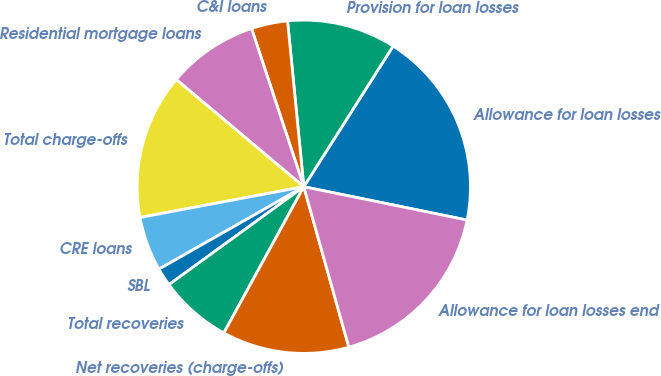<chart> <loc_0><loc_0><loc_500><loc_500><pie_chart><fcel>Allowance for loan losses<fcel>Provision for loan losses<fcel>C&I loans<fcel>Residential mortgage loans<fcel>Total charge-offs<fcel>CRE loans<fcel>SBL<fcel>Total recoveries<fcel>Net recoveries (charge-offs)<fcel>Allowance for loan losses end<nl><fcel>19.2%<fcel>10.56%<fcel>3.52%<fcel>8.8%<fcel>14.08%<fcel>5.28%<fcel>1.76%<fcel>7.04%<fcel>12.32%<fcel>17.44%<nl></chart> 